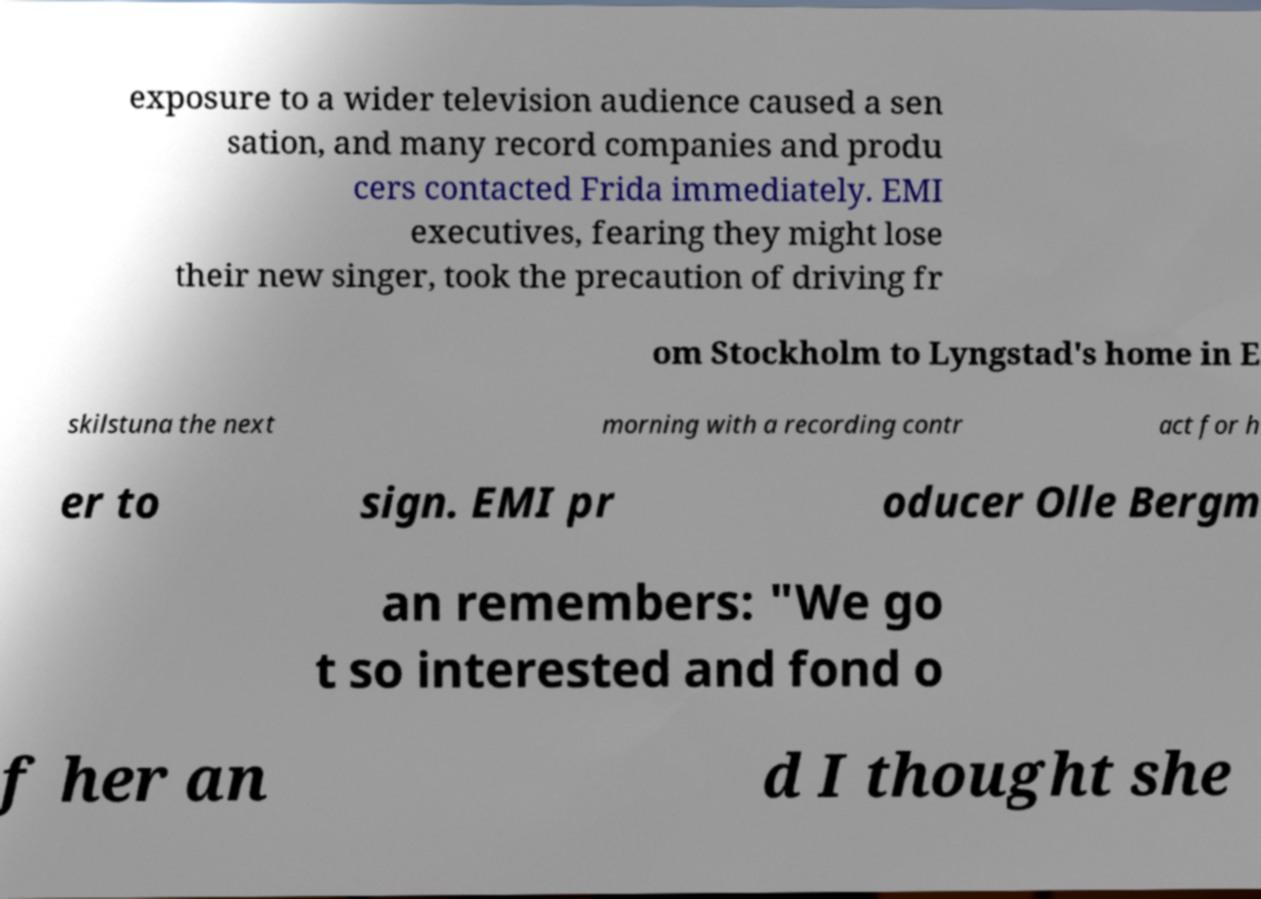There's text embedded in this image that I need extracted. Can you transcribe it verbatim? exposure to a wider television audience caused a sen sation, and many record companies and produ cers contacted Frida immediately. EMI executives, fearing they might lose their new singer, took the precaution of driving fr om Stockholm to Lyngstad's home in E skilstuna the next morning with a recording contr act for h er to sign. EMI pr oducer Olle Bergm an remembers: "We go t so interested and fond o f her an d I thought she 